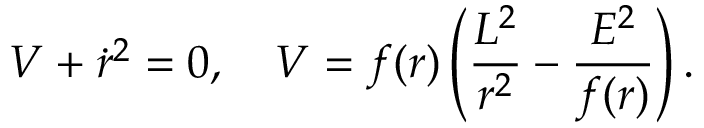Convert formula to latex. <formula><loc_0><loc_0><loc_500><loc_500>V + \dot { r } ^ { 2 } = 0 , V = f ( r ) \left ( \frac { L ^ { 2 } } { r ^ { 2 } } - \frac { E ^ { 2 } } { f ( r ) } \right ) .</formula> 